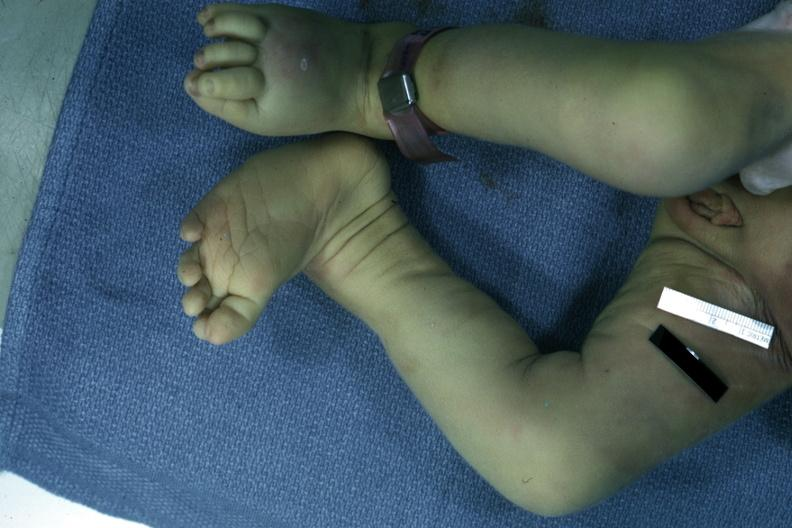does this image show autopsy left club foot?
Answer the question using a single word or phrase. Yes 